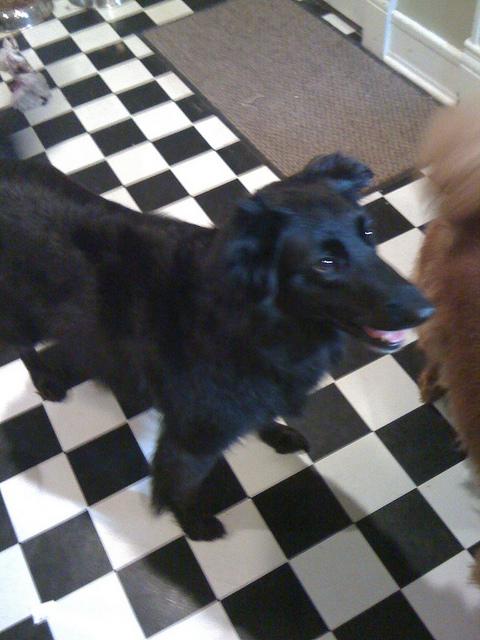Does the snout match the body?
Quick response, please. Yes. What type of pattern is present on the floor?
Write a very short answer. Checkered. Is the dog happy?
Answer briefly. Yes. What color is the dog?
Keep it brief. Black. Where is the dog walking?
Keep it brief. Kitchen. 